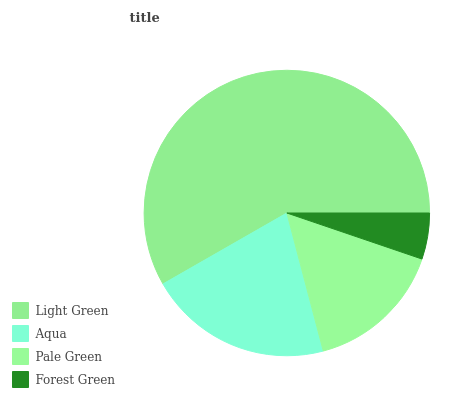Is Forest Green the minimum?
Answer yes or no. Yes. Is Light Green the maximum?
Answer yes or no. Yes. Is Aqua the minimum?
Answer yes or no. No. Is Aqua the maximum?
Answer yes or no. No. Is Light Green greater than Aqua?
Answer yes or no. Yes. Is Aqua less than Light Green?
Answer yes or no. Yes. Is Aqua greater than Light Green?
Answer yes or no. No. Is Light Green less than Aqua?
Answer yes or no. No. Is Aqua the high median?
Answer yes or no. Yes. Is Pale Green the low median?
Answer yes or no. Yes. Is Forest Green the high median?
Answer yes or no. No. Is Forest Green the low median?
Answer yes or no. No. 